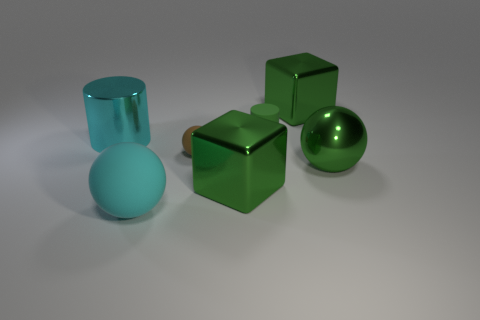There is a green object that is the same shape as the brown thing; what material is it?
Ensure brevity in your answer.  Metal. Do the tiny brown rubber thing and the big cyan matte thing have the same shape?
Ensure brevity in your answer.  Yes. There is a small matte ball; what number of large green spheres are on the right side of it?
Provide a short and direct response. 1. The big green shiny object that is behind the cyan metallic cylinder that is to the left of the large green ball is what shape?
Your response must be concise. Cube. What shape is the cyan object that is the same material as the green ball?
Give a very brief answer. Cylinder. Is the size of the green matte cylinder that is on the right side of the big cylinder the same as the cyan thing right of the cyan cylinder?
Give a very brief answer. No. There is a large cyan matte thing left of the brown sphere; what is its shape?
Provide a short and direct response. Sphere. The small ball is what color?
Make the answer very short. Brown. There is a cyan rubber thing; is it the same size as the brown thing that is on the left side of the matte cylinder?
Keep it short and to the point. No. What number of metallic things are small green things or big brown things?
Give a very brief answer. 0. 